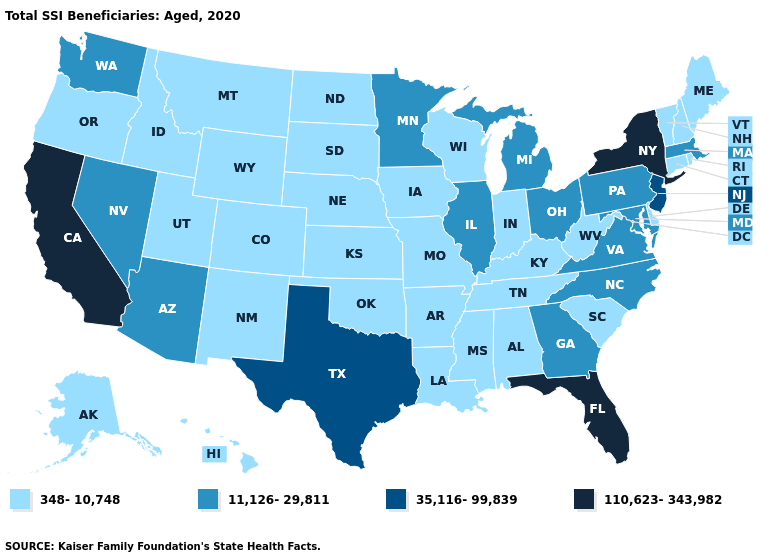What is the value of Florida?
Write a very short answer. 110,623-343,982. Among the states that border Delaware , which have the lowest value?
Write a very short answer. Maryland, Pennsylvania. Is the legend a continuous bar?
Concise answer only. No. What is the value of Mississippi?
Short answer required. 348-10,748. Is the legend a continuous bar?
Concise answer only. No. What is the value of North Carolina?
Answer briefly. 11,126-29,811. Among the states that border Vermont , which have the lowest value?
Answer briefly. New Hampshire. Which states have the lowest value in the MidWest?
Write a very short answer. Indiana, Iowa, Kansas, Missouri, Nebraska, North Dakota, South Dakota, Wisconsin. Does the map have missing data?
Short answer required. No. Does Connecticut have the highest value in the Northeast?
Give a very brief answer. No. Name the states that have a value in the range 11,126-29,811?
Be succinct. Arizona, Georgia, Illinois, Maryland, Massachusetts, Michigan, Minnesota, Nevada, North Carolina, Ohio, Pennsylvania, Virginia, Washington. What is the highest value in the West ?
Be succinct. 110,623-343,982. Does Wisconsin have the highest value in the MidWest?
Be succinct. No. Name the states that have a value in the range 35,116-99,839?
Write a very short answer. New Jersey, Texas. Which states have the lowest value in the USA?
Give a very brief answer. Alabama, Alaska, Arkansas, Colorado, Connecticut, Delaware, Hawaii, Idaho, Indiana, Iowa, Kansas, Kentucky, Louisiana, Maine, Mississippi, Missouri, Montana, Nebraska, New Hampshire, New Mexico, North Dakota, Oklahoma, Oregon, Rhode Island, South Carolina, South Dakota, Tennessee, Utah, Vermont, West Virginia, Wisconsin, Wyoming. 